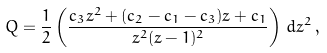Convert formula to latex. <formula><loc_0><loc_0><loc_500><loc_500>Q = \frac { 1 } { 2 } \left ( \frac { c _ { 3 } z ^ { 2 } + ( c _ { 2 } - c _ { 1 } - c _ { 3 } ) z + c _ { 1 } } { z ^ { 2 } ( z - 1 ) ^ { 2 } } \right ) \, d z ^ { 2 } \, ,</formula> 